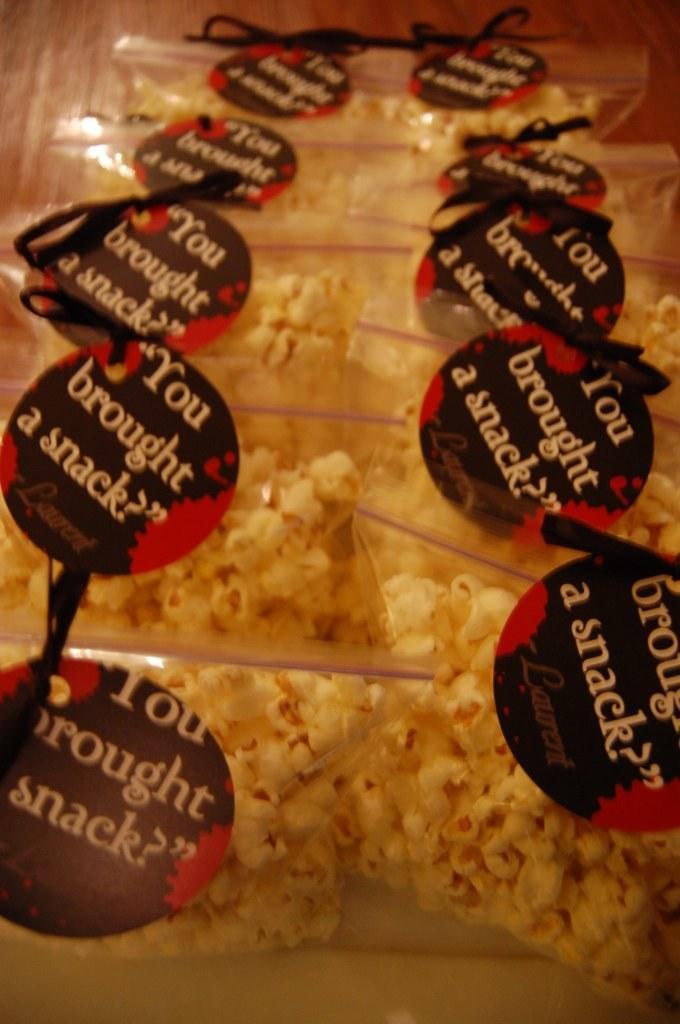In one or two sentences, can you explain what this image depicts? In this image we can see some popcorn packs with tags. 